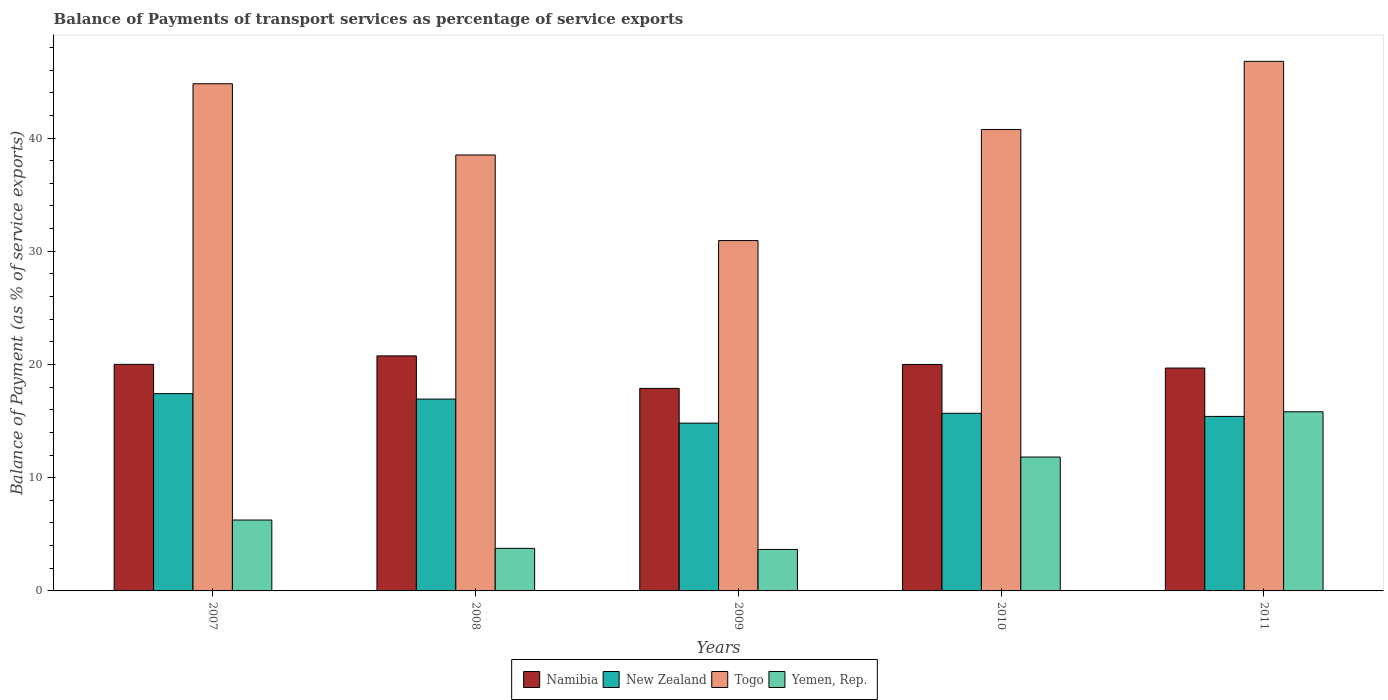How many different coloured bars are there?
Make the answer very short. 4. How many groups of bars are there?
Your answer should be compact. 5. Are the number of bars per tick equal to the number of legend labels?
Your answer should be very brief. Yes. Are the number of bars on each tick of the X-axis equal?
Provide a succinct answer. Yes. How many bars are there on the 4th tick from the right?
Your answer should be compact. 4. What is the label of the 1st group of bars from the left?
Your answer should be compact. 2007. What is the balance of payments of transport services in Togo in 2010?
Your response must be concise. 40.76. Across all years, what is the maximum balance of payments of transport services in Yemen, Rep.?
Offer a terse response. 15.82. Across all years, what is the minimum balance of payments of transport services in Togo?
Ensure brevity in your answer.  30.94. In which year was the balance of payments of transport services in Yemen, Rep. minimum?
Provide a succinct answer. 2009. What is the total balance of payments of transport services in Yemen, Rep. in the graph?
Give a very brief answer. 41.33. What is the difference between the balance of payments of transport services in Togo in 2010 and that in 2011?
Make the answer very short. -6.02. What is the difference between the balance of payments of transport services in Togo in 2007 and the balance of payments of transport services in Namibia in 2010?
Your response must be concise. 24.79. What is the average balance of payments of transport services in Yemen, Rep. per year?
Your response must be concise. 8.27. In the year 2009, what is the difference between the balance of payments of transport services in Namibia and balance of payments of transport services in New Zealand?
Ensure brevity in your answer.  3.07. What is the ratio of the balance of payments of transport services in Togo in 2007 to that in 2009?
Offer a very short reply. 1.45. Is the difference between the balance of payments of transport services in Namibia in 2008 and 2009 greater than the difference between the balance of payments of transport services in New Zealand in 2008 and 2009?
Keep it short and to the point. Yes. What is the difference between the highest and the second highest balance of payments of transport services in New Zealand?
Make the answer very short. 0.48. What is the difference between the highest and the lowest balance of payments of transport services in Togo?
Ensure brevity in your answer.  15.83. In how many years, is the balance of payments of transport services in Yemen, Rep. greater than the average balance of payments of transport services in Yemen, Rep. taken over all years?
Give a very brief answer. 2. What does the 2nd bar from the left in 2009 represents?
Your answer should be compact. New Zealand. What does the 1st bar from the right in 2007 represents?
Your answer should be very brief. Yemen, Rep. How many bars are there?
Your answer should be compact. 20. Are the values on the major ticks of Y-axis written in scientific E-notation?
Ensure brevity in your answer.  No. Does the graph contain grids?
Offer a very short reply. No. How many legend labels are there?
Your answer should be very brief. 4. What is the title of the graph?
Keep it short and to the point. Balance of Payments of transport services as percentage of service exports. Does "Papua New Guinea" appear as one of the legend labels in the graph?
Offer a terse response. No. What is the label or title of the X-axis?
Your answer should be compact. Years. What is the label or title of the Y-axis?
Offer a terse response. Balance of Payment (as % of service exports). What is the Balance of Payment (as % of service exports) in Namibia in 2007?
Your answer should be very brief. 20.01. What is the Balance of Payment (as % of service exports) in New Zealand in 2007?
Provide a succinct answer. 17.42. What is the Balance of Payment (as % of service exports) of Togo in 2007?
Give a very brief answer. 44.79. What is the Balance of Payment (as % of service exports) of Yemen, Rep. in 2007?
Your answer should be very brief. 6.26. What is the Balance of Payment (as % of service exports) in Namibia in 2008?
Your answer should be very brief. 20.76. What is the Balance of Payment (as % of service exports) of New Zealand in 2008?
Offer a very short reply. 16.94. What is the Balance of Payment (as % of service exports) of Togo in 2008?
Make the answer very short. 38.5. What is the Balance of Payment (as % of service exports) of Yemen, Rep. in 2008?
Offer a very short reply. 3.76. What is the Balance of Payment (as % of service exports) in Namibia in 2009?
Your response must be concise. 17.89. What is the Balance of Payment (as % of service exports) of New Zealand in 2009?
Keep it short and to the point. 14.82. What is the Balance of Payment (as % of service exports) of Togo in 2009?
Your answer should be very brief. 30.94. What is the Balance of Payment (as % of service exports) in Yemen, Rep. in 2009?
Provide a succinct answer. 3.66. What is the Balance of Payment (as % of service exports) of Namibia in 2010?
Ensure brevity in your answer.  20. What is the Balance of Payment (as % of service exports) in New Zealand in 2010?
Provide a succinct answer. 15.69. What is the Balance of Payment (as % of service exports) of Togo in 2010?
Make the answer very short. 40.76. What is the Balance of Payment (as % of service exports) of Yemen, Rep. in 2010?
Your response must be concise. 11.82. What is the Balance of Payment (as % of service exports) in Namibia in 2011?
Provide a short and direct response. 19.68. What is the Balance of Payment (as % of service exports) of New Zealand in 2011?
Your response must be concise. 15.41. What is the Balance of Payment (as % of service exports) in Togo in 2011?
Keep it short and to the point. 46.77. What is the Balance of Payment (as % of service exports) in Yemen, Rep. in 2011?
Give a very brief answer. 15.82. Across all years, what is the maximum Balance of Payment (as % of service exports) in Namibia?
Your answer should be very brief. 20.76. Across all years, what is the maximum Balance of Payment (as % of service exports) in New Zealand?
Keep it short and to the point. 17.42. Across all years, what is the maximum Balance of Payment (as % of service exports) of Togo?
Ensure brevity in your answer.  46.77. Across all years, what is the maximum Balance of Payment (as % of service exports) in Yemen, Rep.?
Give a very brief answer. 15.82. Across all years, what is the minimum Balance of Payment (as % of service exports) of Namibia?
Make the answer very short. 17.89. Across all years, what is the minimum Balance of Payment (as % of service exports) of New Zealand?
Provide a succinct answer. 14.82. Across all years, what is the minimum Balance of Payment (as % of service exports) in Togo?
Offer a terse response. 30.94. Across all years, what is the minimum Balance of Payment (as % of service exports) in Yemen, Rep.?
Provide a succinct answer. 3.66. What is the total Balance of Payment (as % of service exports) in Namibia in the graph?
Give a very brief answer. 98.34. What is the total Balance of Payment (as % of service exports) in New Zealand in the graph?
Offer a very short reply. 80.29. What is the total Balance of Payment (as % of service exports) in Togo in the graph?
Keep it short and to the point. 201.77. What is the total Balance of Payment (as % of service exports) of Yemen, Rep. in the graph?
Your answer should be very brief. 41.33. What is the difference between the Balance of Payment (as % of service exports) in Namibia in 2007 and that in 2008?
Keep it short and to the point. -0.75. What is the difference between the Balance of Payment (as % of service exports) in New Zealand in 2007 and that in 2008?
Offer a terse response. 0.48. What is the difference between the Balance of Payment (as % of service exports) in Togo in 2007 and that in 2008?
Give a very brief answer. 6.29. What is the difference between the Balance of Payment (as % of service exports) in Yemen, Rep. in 2007 and that in 2008?
Provide a succinct answer. 2.5. What is the difference between the Balance of Payment (as % of service exports) in Namibia in 2007 and that in 2009?
Make the answer very short. 2.12. What is the difference between the Balance of Payment (as % of service exports) in New Zealand in 2007 and that in 2009?
Provide a short and direct response. 2.6. What is the difference between the Balance of Payment (as % of service exports) of Togo in 2007 and that in 2009?
Ensure brevity in your answer.  13.85. What is the difference between the Balance of Payment (as % of service exports) of Yemen, Rep. in 2007 and that in 2009?
Offer a very short reply. 2.6. What is the difference between the Balance of Payment (as % of service exports) of Namibia in 2007 and that in 2010?
Provide a short and direct response. 0.01. What is the difference between the Balance of Payment (as % of service exports) in New Zealand in 2007 and that in 2010?
Your response must be concise. 1.73. What is the difference between the Balance of Payment (as % of service exports) in Togo in 2007 and that in 2010?
Give a very brief answer. 4.04. What is the difference between the Balance of Payment (as % of service exports) of Yemen, Rep. in 2007 and that in 2010?
Ensure brevity in your answer.  -5.56. What is the difference between the Balance of Payment (as % of service exports) in Namibia in 2007 and that in 2011?
Provide a succinct answer. 0.33. What is the difference between the Balance of Payment (as % of service exports) in New Zealand in 2007 and that in 2011?
Make the answer very short. 2.01. What is the difference between the Balance of Payment (as % of service exports) in Togo in 2007 and that in 2011?
Keep it short and to the point. -1.98. What is the difference between the Balance of Payment (as % of service exports) in Yemen, Rep. in 2007 and that in 2011?
Provide a succinct answer. -9.56. What is the difference between the Balance of Payment (as % of service exports) of Namibia in 2008 and that in 2009?
Your answer should be compact. 2.87. What is the difference between the Balance of Payment (as % of service exports) in New Zealand in 2008 and that in 2009?
Ensure brevity in your answer.  2.12. What is the difference between the Balance of Payment (as % of service exports) of Togo in 2008 and that in 2009?
Offer a very short reply. 7.56. What is the difference between the Balance of Payment (as % of service exports) in Yemen, Rep. in 2008 and that in 2009?
Give a very brief answer. 0.1. What is the difference between the Balance of Payment (as % of service exports) in Namibia in 2008 and that in 2010?
Your response must be concise. 0.76. What is the difference between the Balance of Payment (as % of service exports) in New Zealand in 2008 and that in 2010?
Your answer should be very brief. 1.25. What is the difference between the Balance of Payment (as % of service exports) of Togo in 2008 and that in 2010?
Your answer should be very brief. -2.25. What is the difference between the Balance of Payment (as % of service exports) of Yemen, Rep. in 2008 and that in 2010?
Keep it short and to the point. -8.06. What is the difference between the Balance of Payment (as % of service exports) of Namibia in 2008 and that in 2011?
Ensure brevity in your answer.  1.07. What is the difference between the Balance of Payment (as % of service exports) of New Zealand in 2008 and that in 2011?
Your answer should be compact. 1.53. What is the difference between the Balance of Payment (as % of service exports) of Togo in 2008 and that in 2011?
Your answer should be very brief. -8.27. What is the difference between the Balance of Payment (as % of service exports) in Yemen, Rep. in 2008 and that in 2011?
Keep it short and to the point. -12.06. What is the difference between the Balance of Payment (as % of service exports) in Namibia in 2009 and that in 2010?
Your answer should be very brief. -2.11. What is the difference between the Balance of Payment (as % of service exports) in New Zealand in 2009 and that in 2010?
Provide a succinct answer. -0.87. What is the difference between the Balance of Payment (as % of service exports) of Togo in 2009 and that in 2010?
Provide a short and direct response. -9.81. What is the difference between the Balance of Payment (as % of service exports) of Yemen, Rep. in 2009 and that in 2010?
Your response must be concise. -8.16. What is the difference between the Balance of Payment (as % of service exports) in Namibia in 2009 and that in 2011?
Your answer should be very brief. -1.79. What is the difference between the Balance of Payment (as % of service exports) of New Zealand in 2009 and that in 2011?
Offer a very short reply. -0.59. What is the difference between the Balance of Payment (as % of service exports) of Togo in 2009 and that in 2011?
Keep it short and to the point. -15.83. What is the difference between the Balance of Payment (as % of service exports) of Yemen, Rep. in 2009 and that in 2011?
Provide a short and direct response. -12.16. What is the difference between the Balance of Payment (as % of service exports) of Namibia in 2010 and that in 2011?
Keep it short and to the point. 0.32. What is the difference between the Balance of Payment (as % of service exports) of New Zealand in 2010 and that in 2011?
Offer a very short reply. 0.28. What is the difference between the Balance of Payment (as % of service exports) of Togo in 2010 and that in 2011?
Provide a succinct answer. -6.02. What is the difference between the Balance of Payment (as % of service exports) of Yemen, Rep. in 2010 and that in 2011?
Ensure brevity in your answer.  -4. What is the difference between the Balance of Payment (as % of service exports) of Namibia in 2007 and the Balance of Payment (as % of service exports) of New Zealand in 2008?
Your answer should be compact. 3.07. What is the difference between the Balance of Payment (as % of service exports) of Namibia in 2007 and the Balance of Payment (as % of service exports) of Togo in 2008?
Make the answer very short. -18.49. What is the difference between the Balance of Payment (as % of service exports) in Namibia in 2007 and the Balance of Payment (as % of service exports) in Yemen, Rep. in 2008?
Ensure brevity in your answer.  16.25. What is the difference between the Balance of Payment (as % of service exports) in New Zealand in 2007 and the Balance of Payment (as % of service exports) in Togo in 2008?
Keep it short and to the point. -21.08. What is the difference between the Balance of Payment (as % of service exports) of New Zealand in 2007 and the Balance of Payment (as % of service exports) of Yemen, Rep. in 2008?
Provide a short and direct response. 13.66. What is the difference between the Balance of Payment (as % of service exports) in Togo in 2007 and the Balance of Payment (as % of service exports) in Yemen, Rep. in 2008?
Provide a short and direct response. 41.03. What is the difference between the Balance of Payment (as % of service exports) of Namibia in 2007 and the Balance of Payment (as % of service exports) of New Zealand in 2009?
Keep it short and to the point. 5.19. What is the difference between the Balance of Payment (as % of service exports) of Namibia in 2007 and the Balance of Payment (as % of service exports) of Togo in 2009?
Provide a succinct answer. -10.93. What is the difference between the Balance of Payment (as % of service exports) in Namibia in 2007 and the Balance of Payment (as % of service exports) in Yemen, Rep. in 2009?
Your answer should be compact. 16.35. What is the difference between the Balance of Payment (as % of service exports) of New Zealand in 2007 and the Balance of Payment (as % of service exports) of Togo in 2009?
Provide a short and direct response. -13.52. What is the difference between the Balance of Payment (as % of service exports) in New Zealand in 2007 and the Balance of Payment (as % of service exports) in Yemen, Rep. in 2009?
Keep it short and to the point. 13.76. What is the difference between the Balance of Payment (as % of service exports) of Togo in 2007 and the Balance of Payment (as % of service exports) of Yemen, Rep. in 2009?
Provide a succinct answer. 41.13. What is the difference between the Balance of Payment (as % of service exports) in Namibia in 2007 and the Balance of Payment (as % of service exports) in New Zealand in 2010?
Offer a terse response. 4.32. What is the difference between the Balance of Payment (as % of service exports) in Namibia in 2007 and the Balance of Payment (as % of service exports) in Togo in 2010?
Offer a terse response. -20.75. What is the difference between the Balance of Payment (as % of service exports) of Namibia in 2007 and the Balance of Payment (as % of service exports) of Yemen, Rep. in 2010?
Make the answer very short. 8.19. What is the difference between the Balance of Payment (as % of service exports) of New Zealand in 2007 and the Balance of Payment (as % of service exports) of Togo in 2010?
Keep it short and to the point. -23.33. What is the difference between the Balance of Payment (as % of service exports) in New Zealand in 2007 and the Balance of Payment (as % of service exports) in Yemen, Rep. in 2010?
Provide a short and direct response. 5.6. What is the difference between the Balance of Payment (as % of service exports) in Togo in 2007 and the Balance of Payment (as % of service exports) in Yemen, Rep. in 2010?
Keep it short and to the point. 32.97. What is the difference between the Balance of Payment (as % of service exports) of Namibia in 2007 and the Balance of Payment (as % of service exports) of New Zealand in 2011?
Keep it short and to the point. 4.6. What is the difference between the Balance of Payment (as % of service exports) in Namibia in 2007 and the Balance of Payment (as % of service exports) in Togo in 2011?
Provide a short and direct response. -26.76. What is the difference between the Balance of Payment (as % of service exports) in Namibia in 2007 and the Balance of Payment (as % of service exports) in Yemen, Rep. in 2011?
Give a very brief answer. 4.19. What is the difference between the Balance of Payment (as % of service exports) of New Zealand in 2007 and the Balance of Payment (as % of service exports) of Togo in 2011?
Your answer should be very brief. -29.35. What is the difference between the Balance of Payment (as % of service exports) in New Zealand in 2007 and the Balance of Payment (as % of service exports) in Yemen, Rep. in 2011?
Your answer should be very brief. 1.6. What is the difference between the Balance of Payment (as % of service exports) in Togo in 2007 and the Balance of Payment (as % of service exports) in Yemen, Rep. in 2011?
Keep it short and to the point. 28.97. What is the difference between the Balance of Payment (as % of service exports) in Namibia in 2008 and the Balance of Payment (as % of service exports) in New Zealand in 2009?
Give a very brief answer. 5.94. What is the difference between the Balance of Payment (as % of service exports) of Namibia in 2008 and the Balance of Payment (as % of service exports) of Togo in 2009?
Your response must be concise. -10.19. What is the difference between the Balance of Payment (as % of service exports) in Namibia in 2008 and the Balance of Payment (as % of service exports) in Yemen, Rep. in 2009?
Offer a very short reply. 17.09. What is the difference between the Balance of Payment (as % of service exports) of New Zealand in 2008 and the Balance of Payment (as % of service exports) of Togo in 2009?
Make the answer very short. -14. What is the difference between the Balance of Payment (as % of service exports) in New Zealand in 2008 and the Balance of Payment (as % of service exports) in Yemen, Rep. in 2009?
Provide a succinct answer. 13.28. What is the difference between the Balance of Payment (as % of service exports) of Togo in 2008 and the Balance of Payment (as % of service exports) of Yemen, Rep. in 2009?
Your response must be concise. 34.84. What is the difference between the Balance of Payment (as % of service exports) of Namibia in 2008 and the Balance of Payment (as % of service exports) of New Zealand in 2010?
Provide a succinct answer. 5.07. What is the difference between the Balance of Payment (as % of service exports) of Namibia in 2008 and the Balance of Payment (as % of service exports) of Togo in 2010?
Make the answer very short. -20. What is the difference between the Balance of Payment (as % of service exports) in Namibia in 2008 and the Balance of Payment (as % of service exports) in Yemen, Rep. in 2010?
Make the answer very short. 8.93. What is the difference between the Balance of Payment (as % of service exports) of New Zealand in 2008 and the Balance of Payment (as % of service exports) of Togo in 2010?
Make the answer very short. -23.81. What is the difference between the Balance of Payment (as % of service exports) of New Zealand in 2008 and the Balance of Payment (as % of service exports) of Yemen, Rep. in 2010?
Provide a short and direct response. 5.12. What is the difference between the Balance of Payment (as % of service exports) of Togo in 2008 and the Balance of Payment (as % of service exports) of Yemen, Rep. in 2010?
Offer a very short reply. 26.68. What is the difference between the Balance of Payment (as % of service exports) in Namibia in 2008 and the Balance of Payment (as % of service exports) in New Zealand in 2011?
Your answer should be very brief. 5.34. What is the difference between the Balance of Payment (as % of service exports) of Namibia in 2008 and the Balance of Payment (as % of service exports) of Togo in 2011?
Your answer should be compact. -26.01. What is the difference between the Balance of Payment (as % of service exports) of Namibia in 2008 and the Balance of Payment (as % of service exports) of Yemen, Rep. in 2011?
Ensure brevity in your answer.  4.94. What is the difference between the Balance of Payment (as % of service exports) in New Zealand in 2008 and the Balance of Payment (as % of service exports) in Togo in 2011?
Your answer should be very brief. -29.83. What is the difference between the Balance of Payment (as % of service exports) in New Zealand in 2008 and the Balance of Payment (as % of service exports) in Yemen, Rep. in 2011?
Keep it short and to the point. 1.12. What is the difference between the Balance of Payment (as % of service exports) of Togo in 2008 and the Balance of Payment (as % of service exports) of Yemen, Rep. in 2011?
Make the answer very short. 22.68. What is the difference between the Balance of Payment (as % of service exports) in Namibia in 2009 and the Balance of Payment (as % of service exports) in New Zealand in 2010?
Your answer should be very brief. 2.2. What is the difference between the Balance of Payment (as % of service exports) in Namibia in 2009 and the Balance of Payment (as % of service exports) in Togo in 2010?
Your answer should be compact. -22.87. What is the difference between the Balance of Payment (as % of service exports) of Namibia in 2009 and the Balance of Payment (as % of service exports) of Yemen, Rep. in 2010?
Keep it short and to the point. 6.07. What is the difference between the Balance of Payment (as % of service exports) in New Zealand in 2009 and the Balance of Payment (as % of service exports) in Togo in 2010?
Offer a very short reply. -25.93. What is the difference between the Balance of Payment (as % of service exports) of New Zealand in 2009 and the Balance of Payment (as % of service exports) of Yemen, Rep. in 2010?
Offer a terse response. 3. What is the difference between the Balance of Payment (as % of service exports) in Togo in 2009 and the Balance of Payment (as % of service exports) in Yemen, Rep. in 2010?
Provide a succinct answer. 19.12. What is the difference between the Balance of Payment (as % of service exports) of Namibia in 2009 and the Balance of Payment (as % of service exports) of New Zealand in 2011?
Your answer should be compact. 2.48. What is the difference between the Balance of Payment (as % of service exports) in Namibia in 2009 and the Balance of Payment (as % of service exports) in Togo in 2011?
Your answer should be compact. -28.88. What is the difference between the Balance of Payment (as % of service exports) of Namibia in 2009 and the Balance of Payment (as % of service exports) of Yemen, Rep. in 2011?
Give a very brief answer. 2.07. What is the difference between the Balance of Payment (as % of service exports) of New Zealand in 2009 and the Balance of Payment (as % of service exports) of Togo in 2011?
Provide a succinct answer. -31.95. What is the difference between the Balance of Payment (as % of service exports) of New Zealand in 2009 and the Balance of Payment (as % of service exports) of Yemen, Rep. in 2011?
Your answer should be compact. -1. What is the difference between the Balance of Payment (as % of service exports) of Togo in 2009 and the Balance of Payment (as % of service exports) of Yemen, Rep. in 2011?
Provide a succinct answer. 15.12. What is the difference between the Balance of Payment (as % of service exports) in Namibia in 2010 and the Balance of Payment (as % of service exports) in New Zealand in 2011?
Keep it short and to the point. 4.59. What is the difference between the Balance of Payment (as % of service exports) of Namibia in 2010 and the Balance of Payment (as % of service exports) of Togo in 2011?
Your answer should be compact. -26.77. What is the difference between the Balance of Payment (as % of service exports) in Namibia in 2010 and the Balance of Payment (as % of service exports) in Yemen, Rep. in 2011?
Your answer should be very brief. 4.18. What is the difference between the Balance of Payment (as % of service exports) in New Zealand in 2010 and the Balance of Payment (as % of service exports) in Togo in 2011?
Offer a very short reply. -31.08. What is the difference between the Balance of Payment (as % of service exports) of New Zealand in 2010 and the Balance of Payment (as % of service exports) of Yemen, Rep. in 2011?
Your answer should be compact. -0.13. What is the difference between the Balance of Payment (as % of service exports) of Togo in 2010 and the Balance of Payment (as % of service exports) of Yemen, Rep. in 2011?
Your answer should be very brief. 24.93. What is the average Balance of Payment (as % of service exports) in Namibia per year?
Keep it short and to the point. 19.67. What is the average Balance of Payment (as % of service exports) of New Zealand per year?
Make the answer very short. 16.06. What is the average Balance of Payment (as % of service exports) of Togo per year?
Offer a terse response. 40.35. What is the average Balance of Payment (as % of service exports) in Yemen, Rep. per year?
Provide a short and direct response. 8.27. In the year 2007, what is the difference between the Balance of Payment (as % of service exports) of Namibia and Balance of Payment (as % of service exports) of New Zealand?
Offer a very short reply. 2.59. In the year 2007, what is the difference between the Balance of Payment (as % of service exports) of Namibia and Balance of Payment (as % of service exports) of Togo?
Your answer should be very brief. -24.78. In the year 2007, what is the difference between the Balance of Payment (as % of service exports) in Namibia and Balance of Payment (as % of service exports) in Yemen, Rep.?
Offer a very short reply. 13.75. In the year 2007, what is the difference between the Balance of Payment (as % of service exports) of New Zealand and Balance of Payment (as % of service exports) of Togo?
Offer a very short reply. -27.37. In the year 2007, what is the difference between the Balance of Payment (as % of service exports) of New Zealand and Balance of Payment (as % of service exports) of Yemen, Rep.?
Offer a terse response. 11.16. In the year 2007, what is the difference between the Balance of Payment (as % of service exports) of Togo and Balance of Payment (as % of service exports) of Yemen, Rep.?
Offer a very short reply. 38.53. In the year 2008, what is the difference between the Balance of Payment (as % of service exports) of Namibia and Balance of Payment (as % of service exports) of New Zealand?
Your response must be concise. 3.81. In the year 2008, what is the difference between the Balance of Payment (as % of service exports) of Namibia and Balance of Payment (as % of service exports) of Togo?
Keep it short and to the point. -17.75. In the year 2008, what is the difference between the Balance of Payment (as % of service exports) in Namibia and Balance of Payment (as % of service exports) in Yemen, Rep.?
Provide a short and direct response. 17. In the year 2008, what is the difference between the Balance of Payment (as % of service exports) in New Zealand and Balance of Payment (as % of service exports) in Togo?
Provide a succinct answer. -21.56. In the year 2008, what is the difference between the Balance of Payment (as % of service exports) of New Zealand and Balance of Payment (as % of service exports) of Yemen, Rep.?
Keep it short and to the point. 13.18. In the year 2008, what is the difference between the Balance of Payment (as % of service exports) in Togo and Balance of Payment (as % of service exports) in Yemen, Rep.?
Provide a short and direct response. 34.74. In the year 2009, what is the difference between the Balance of Payment (as % of service exports) of Namibia and Balance of Payment (as % of service exports) of New Zealand?
Provide a succinct answer. 3.07. In the year 2009, what is the difference between the Balance of Payment (as % of service exports) in Namibia and Balance of Payment (as % of service exports) in Togo?
Offer a very short reply. -13.05. In the year 2009, what is the difference between the Balance of Payment (as % of service exports) of Namibia and Balance of Payment (as % of service exports) of Yemen, Rep.?
Offer a very short reply. 14.23. In the year 2009, what is the difference between the Balance of Payment (as % of service exports) in New Zealand and Balance of Payment (as % of service exports) in Togo?
Ensure brevity in your answer.  -16.12. In the year 2009, what is the difference between the Balance of Payment (as % of service exports) of New Zealand and Balance of Payment (as % of service exports) of Yemen, Rep.?
Ensure brevity in your answer.  11.16. In the year 2009, what is the difference between the Balance of Payment (as % of service exports) of Togo and Balance of Payment (as % of service exports) of Yemen, Rep.?
Your response must be concise. 27.28. In the year 2010, what is the difference between the Balance of Payment (as % of service exports) in Namibia and Balance of Payment (as % of service exports) in New Zealand?
Your answer should be compact. 4.31. In the year 2010, what is the difference between the Balance of Payment (as % of service exports) in Namibia and Balance of Payment (as % of service exports) in Togo?
Your answer should be very brief. -20.75. In the year 2010, what is the difference between the Balance of Payment (as % of service exports) of Namibia and Balance of Payment (as % of service exports) of Yemen, Rep.?
Your answer should be very brief. 8.18. In the year 2010, what is the difference between the Balance of Payment (as % of service exports) in New Zealand and Balance of Payment (as % of service exports) in Togo?
Your answer should be compact. -25.07. In the year 2010, what is the difference between the Balance of Payment (as % of service exports) in New Zealand and Balance of Payment (as % of service exports) in Yemen, Rep.?
Make the answer very short. 3.87. In the year 2010, what is the difference between the Balance of Payment (as % of service exports) in Togo and Balance of Payment (as % of service exports) in Yemen, Rep.?
Make the answer very short. 28.93. In the year 2011, what is the difference between the Balance of Payment (as % of service exports) of Namibia and Balance of Payment (as % of service exports) of New Zealand?
Provide a short and direct response. 4.27. In the year 2011, what is the difference between the Balance of Payment (as % of service exports) of Namibia and Balance of Payment (as % of service exports) of Togo?
Make the answer very short. -27.09. In the year 2011, what is the difference between the Balance of Payment (as % of service exports) in Namibia and Balance of Payment (as % of service exports) in Yemen, Rep.?
Ensure brevity in your answer.  3.86. In the year 2011, what is the difference between the Balance of Payment (as % of service exports) of New Zealand and Balance of Payment (as % of service exports) of Togo?
Give a very brief answer. -31.36. In the year 2011, what is the difference between the Balance of Payment (as % of service exports) of New Zealand and Balance of Payment (as % of service exports) of Yemen, Rep.?
Provide a succinct answer. -0.41. In the year 2011, what is the difference between the Balance of Payment (as % of service exports) in Togo and Balance of Payment (as % of service exports) in Yemen, Rep.?
Provide a succinct answer. 30.95. What is the ratio of the Balance of Payment (as % of service exports) in Namibia in 2007 to that in 2008?
Provide a succinct answer. 0.96. What is the ratio of the Balance of Payment (as % of service exports) of New Zealand in 2007 to that in 2008?
Your answer should be compact. 1.03. What is the ratio of the Balance of Payment (as % of service exports) in Togo in 2007 to that in 2008?
Offer a very short reply. 1.16. What is the ratio of the Balance of Payment (as % of service exports) in Yemen, Rep. in 2007 to that in 2008?
Your response must be concise. 1.67. What is the ratio of the Balance of Payment (as % of service exports) in Namibia in 2007 to that in 2009?
Your response must be concise. 1.12. What is the ratio of the Balance of Payment (as % of service exports) of New Zealand in 2007 to that in 2009?
Offer a terse response. 1.18. What is the ratio of the Balance of Payment (as % of service exports) of Togo in 2007 to that in 2009?
Offer a terse response. 1.45. What is the ratio of the Balance of Payment (as % of service exports) of Yemen, Rep. in 2007 to that in 2009?
Provide a succinct answer. 1.71. What is the ratio of the Balance of Payment (as % of service exports) in New Zealand in 2007 to that in 2010?
Keep it short and to the point. 1.11. What is the ratio of the Balance of Payment (as % of service exports) in Togo in 2007 to that in 2010?
Give a very brief answer. 1.1. What is the ratio of the Balance of Payment (as % of service exports) of Yemen, Rep. in 2007 to that in 2010?
Offer a very short reply. 0.53. What is the ratio of the Balance of Payment (as % of service exports) in Namibia in 2007 to that in 2011?
Ensure brevity in your answer.  1.02. What is the ratio of the Balance of Payment (as % of service exports) of New Zealand in 2007 to that in 2011?
Keep it short and to the point. 1.13. What is the ratio of the Balance of Payment (as % of service exports) in Togo in 2007 to that in 2011?
Offer a very short reply. 0.96. What is the ratio of the Balance of Payment (as % of service exports) of Yemen, Rep. in 2007 to that in 2011?
Make the answer very short. 0.4. What is the ratio of the Balance of Payment (as % of service exports) of Namibia in 2008 to that in 2009?
Keep it short and to the point. 1.16. What is the ratio of the Balance of Payment (as % of service exports) of New Zealand in 2008 to that in 2009?
Provide a succinct answer. 1.14. What is the ratio of the Balance of Payment (as % of service exports) of Togo in 2008 to that in 2009?
Ensure brevity in your answer.  1.24. What is the ratio of the Balance of Payment (as % of service exports) of Yemen, Rep. in 2008 to that in 2009?
Your answer should be compact. 1.03. What is the ratio of the Balance of Payment (as % of service exports) in Namibia in 2008 to that in 2010?
Keep it short and to the point. 1.04. What is the ratio of the Balance of Payment (as % of service exports) in New Zealand in 2008 to that in 2010?
Provide a succinct answer. 1.08. What is the ratio of the Balance of Payment (as % of service exports) in Togo in 2008 to that in 2010?
Provide a short and direct response. 0.94. What is the ratio of the Balance of Payment (as % of service exports) of Yemen, Rep. in 2008 to that in 2010?
Your answer should be compact. 0.32. What is the ratio of the Balance of Payment (as % of service exports) in Namibia in 2008 to that in 2011?
Offer a terse response. 1.05. What is the ratio of the Balance of Payment (as % of service exports) of New Zealand in 2008 to that in 2011?
Ensure brevity in your answer.  1.1. What is the ratio of the Balance of Payment (as % of service exports) in Togo in 2008 to that in 2011?
Provide a succinct answer. 0.82. What is the ratio of the Balance of Payment (as % of service exports) of Yemen, Rep. in 2008 to that in 2011?
Your answer should be very brief. 0.24. What is the ratio of the Balance of Payment (as % of service exports) of Namibia in 2009 to that in 2010?
Provide a succinct answer. 0.89. What is the ratio of the Balance of Payment (as % of service exports) in New Zealand in 2009 to that in 2010?
Provide a succinct answer. 0.94. What is the ratio of the Balance of Payment (as % of service exports) in Togo in 2009 to that in 2010?
Your response must be concise. 0.76. What is the ratio of the Balance of Payment (as % of service exports) of Yemen, Rep. in 2009 to that in 2010?
Make the answer very short. 0.31. What is the ratio of the Balance of Payment (as % of service exports) in Namibia in 2009 to that in 2011?
Keep it short and to the point. 0.91. What is the ratio of the Balance of Payment (as % of service exports) of New Zealand in 2009 to that in 2011?
Make the answer very short. 0.96. What is the ratio of the Balance of Payment (as % of service exports) in Togo in 2009 to that in 2011?
Offer a terse response. 0.66. What is the ratio of the Balance of Payment (as % of service exports) of Yemen, Rep. in 2009 to that in 2011?
Keep it short and to the point. 0.23. What is the ratio of the Balance of Payment (as % of service exports) of Namibia in 2010 to that in 2011?
Provide a succinct answer. 1.02. What is the ratio of the Balance of Payment (as % of service exports) in New Zealand in 2010 to that in 2011?
Provide a succinct answer. 1.02. What is the ratio of the Balance of Payment (as % of service exports) in Togo in 2010 to that in 2011?
Provide a short and direct response. 0.87. What is the ratio of the Balance of Payment (as % of service exports) of Yemen, Rep. in 2010 to that in 2011?
Keep it short and to the point. 0.75. What is the difference between the highest and the second highest Balance of Payment (as % of service exports) in Namibia?
Ensure brevity in your answer.  0.75. What is the difference between the highest and the second highest Balance of Payment (as % of service exports) in New Zealand?
Make the answer very short. 0.48. What is the difference between the highest and the second highest Balance of Payment (as % of service exports) of Togo?
Provide a short and direct response. 1.98. What is the difference between the highest and the second highest Balance of Payment (as % of service exports) in Yemen, Rep.?
Offer a terse response. 4. What is the difference between the highest and the lowest Balance of Payment (as % of service exports) of Namibia?
Your answer should be compact. 2.87. What is the difference between the highest and the lowest Balance of Payment (as % of service exports) in New Zealand?
Offer a very short reply. 2.6. What is the difference between the highest and the lowest Balance of Payment (as % of service exports) of Togo?
Give a very brief answer. 15.83. What is the difference between the highest and the lowest Balance of Payment (as % of service exports) of Yemen, Rep.?
Make the answer very short. 12.16. 